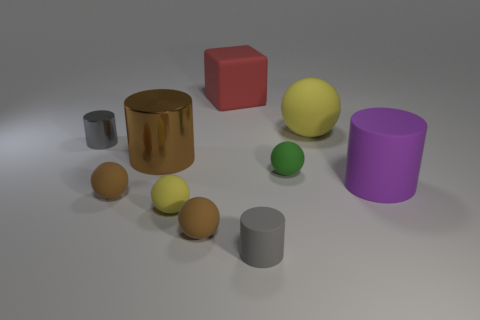How many spheres are either gray things or green rubber objects?
Offer a very short reply. 1. Is there anything else that is the same color as the large ball?
Provide a short and direct response. Yes. What material is the tiny gray thing that is behind the small matte sphere that is behind the big purple thing?
Give a very brief answer. Metal. Do the big red cube and the small ball that is on the right side of the red matte cube have the same material?
Your answer should be compact. Yes. What number of things are either cylinders right of the brown cylinder or large red matte objects?
Offer a terse response. 3. Are there any spheres of the same color as the matte block?
Keep it short and to the point. No. Does the tiny yellow rubber thing have the same shape as the small gray thing in front of the big purple cylinder?
Your answer should be very brief. No. How many matte spheres are both in front of the large purple matte thing and behind the small gray metallic thing?
Offer a terse response. 0. What material is the big brown thing that is the same shape as the tiny metal thing?
Offer a very short reply. Metal. There is a gray cylinder on the left side of the gray object that is in front of the big brown cylinder; what is its size?
Provide a short and direct response. Small. 